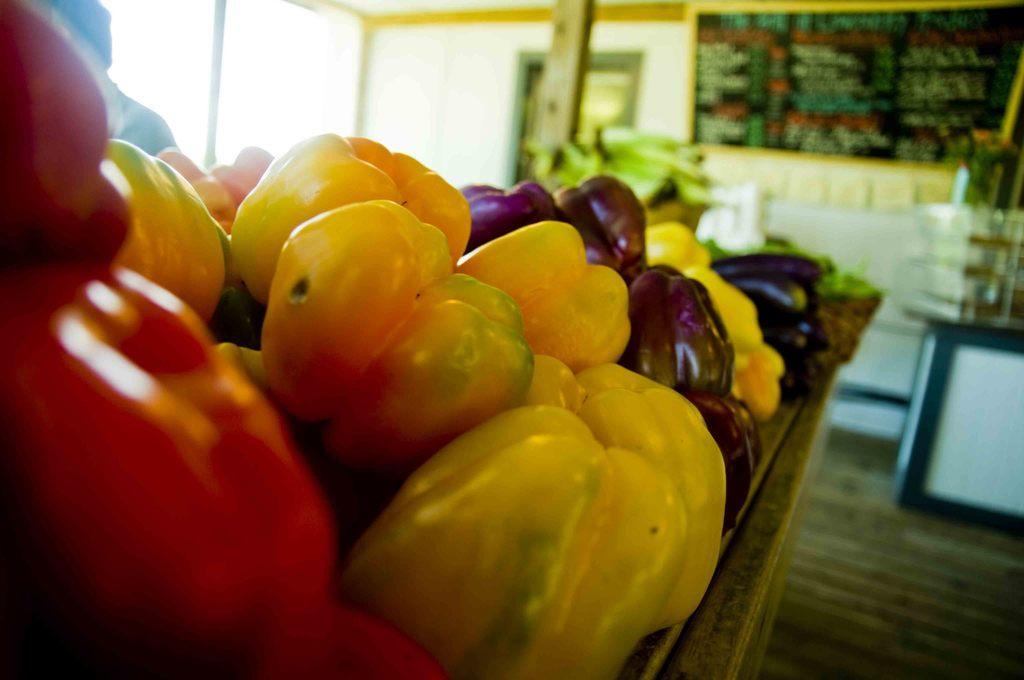How would you summarize this image in a sentence or two? In this image we can see some vegetables on the table, some of them are capsicums, brinjals and other, in the background, we can see the wall, on the wall there is a photo frame and also we can see a person. 